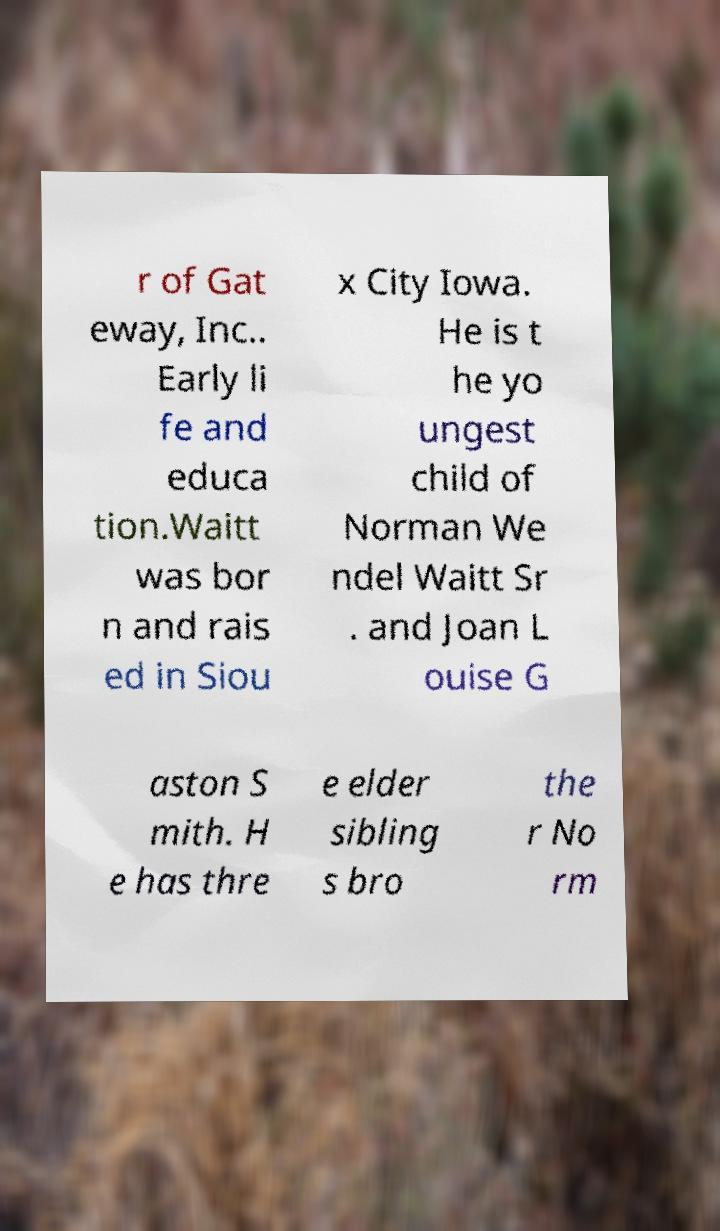Can you accurately transcribe the text from the provided image for me? r of Gat eway, Inc.. Early li fe and educa tion.Waitt was bor n and rais ed in Siou x City Iowa. He is t he yo ungest child of Norman We ndel Waitt Sr . and Joan L ouise G aston S mith. H e has thre e elder sibling s bro the r No rm 